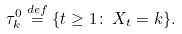Convert formula to latex. <formula><loc_0><loc_0><loc_500><loc_500>\tau ^ { 0 } _ { k } \stackrel { d e f } { = } \{ t \geq 1 \colon \, X _ { t } = k \} .</formula> 